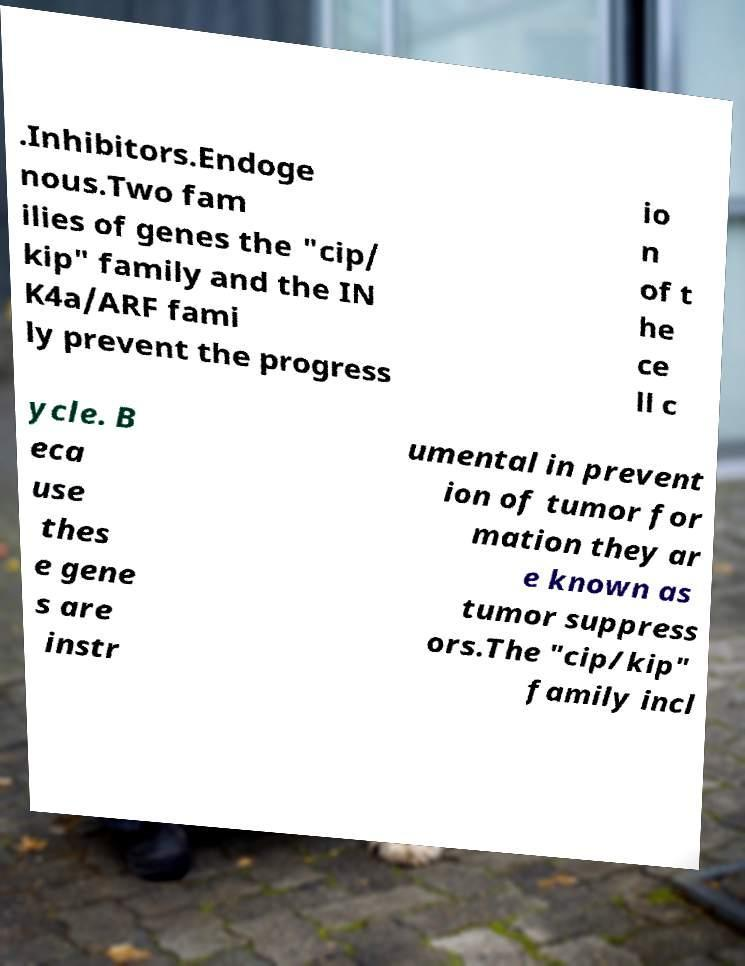Please read and relay the text visible in this image. What does it say? .Inhibitors.Endoge nous.Two fam ilies of genes the "cip/ kip" family and the IN K4a/ARF fami ly prevent the progress io n of t he ce ll c ycle. B eca use thes e gene s are instr umental in prevent ion of tumor for mation they ar e known as tumor suppress ors.The "cip/kip" family incl 